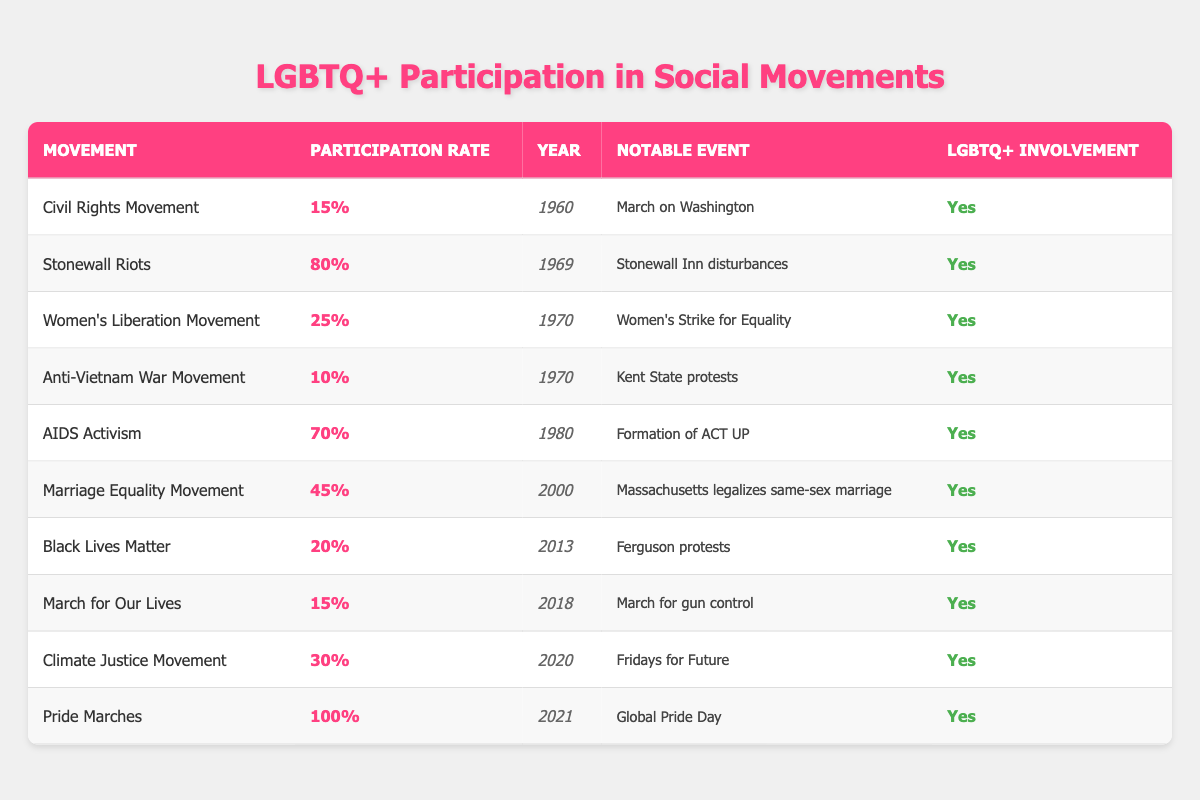What was the participation rate of LGBTQ+ individuals in the Stonewall Riots? According to the table, the Stonewall Riots had a participation rate of 80% for LGBTQ+ individuals.
Answer: 80% Which social movement had the lowest participation rate of LGBTQ+ individuals? The Anti-Vietnam War Movement had the lowest participation rate at 10%.
Answer: 10% What notable event is associated with the Civil Rights Movement? The notable event associated with the Civil Rights Movement is the March on Washington, as stated in the table.
Answer: March on Washington Was there LGBTQ+ involvement in the Marriage Equality Movement? Yes, the table indicates that there was LGBTQ+ involvement in the Marriage Equality Movement.
Answer: Yes What is the average participation rate of LGBTQ+ individuals across all movements listed? To find the average, we sum the participation rates: 15 + 80 + 25 + 10 + 70 + 45 + 20 + 15 + 30 + 100 = 405. There are 10 movements, so the average is 405 / 10 = 40.5.
Answer: 40.5 In what year was the highest participation rate recorded for LGBTQ+ individuals, and what was that rate? The highest participation rate recorded was 100% in the year 2021 during the Pride Marches.
Answer: 2021, 100% How many movements had a participation rate of 30% or higher? The movements with participation rates of 30% or higher are: Stonewall Riots (80%), AIDS Activism (70%), Marriage Equality Movement (45%), Pride Marches (100%). This totals 4 movements.
Answer: 4 What percentage of LGBTQ+ participants were involved in the Black Lives Matter movement? The table shows that 20% of LGBTQ+ individuals participated in the Black Lives Matter movement.
Answer: 20% Which movement had a notable event regarding gun control? The March for Our Lives had a notable event focused on gun control, as indicated in the table.
Answer: March for Our Lives 